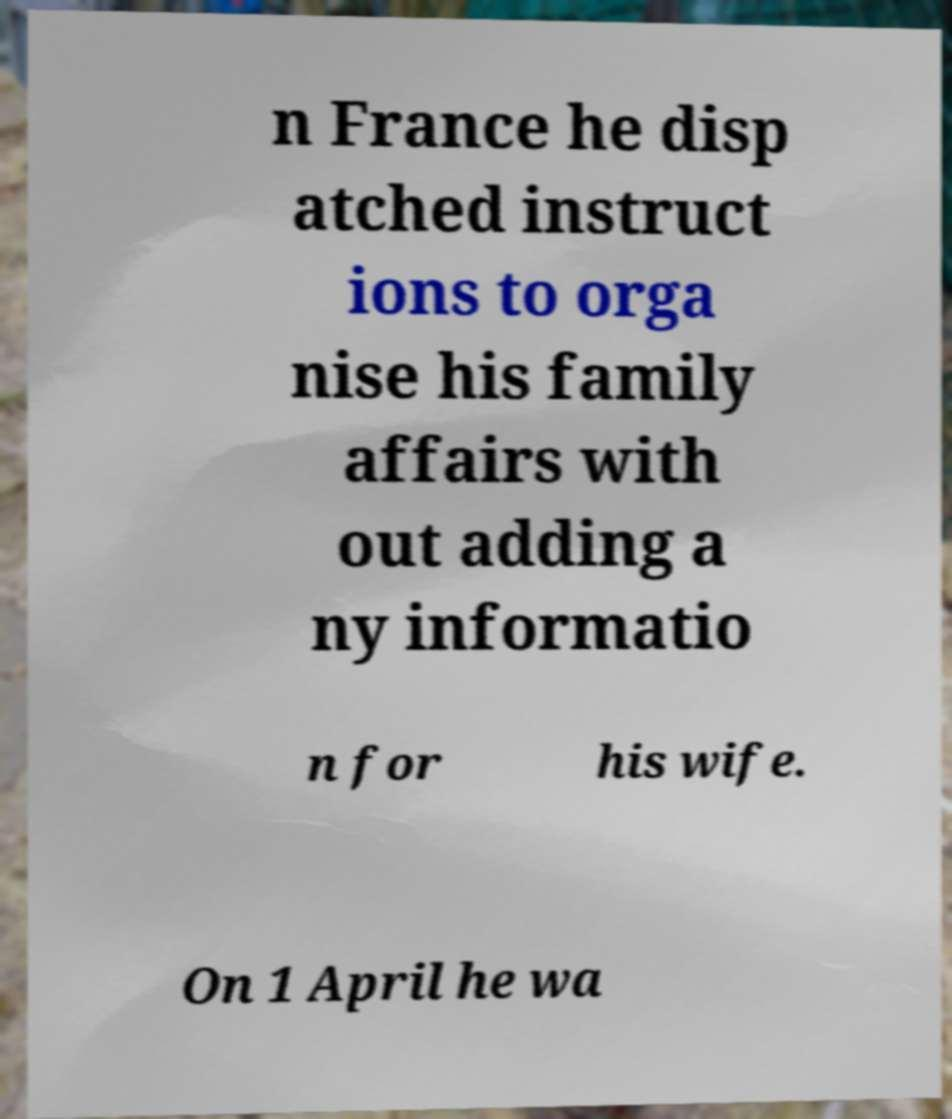For documentation purposes, I need the text within this image transcribed. Could you provide that? n France he disp atched instruct ions to orga nise his family affairs with out adding a ny informatio n for his wife. On 1 April he wa 